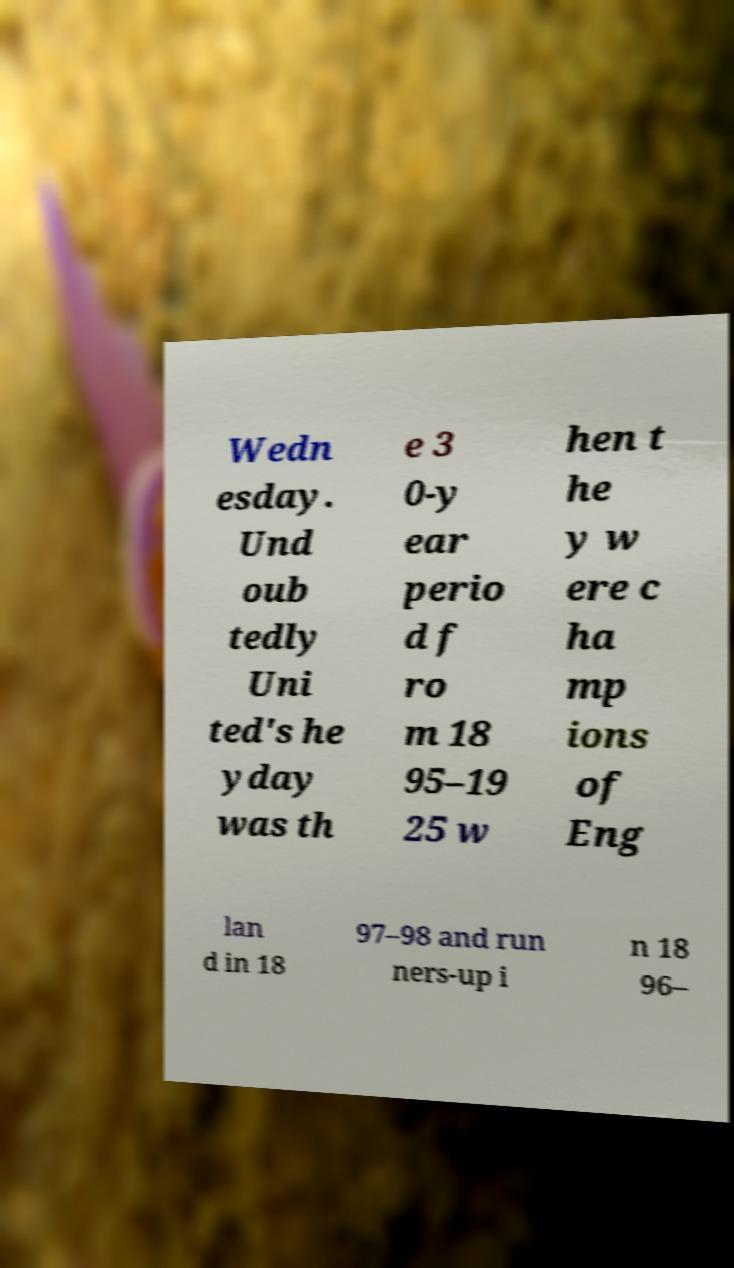I need the written content from this picture converted into text. Can you do that? Wedn esday. Und oub tedly Uni ted's he yday was th e 3 0-y ear perio d f ro m 18 95–19 25 w hen t he y w ere c ha mp ions of Eng lan d in 18 97–98 and run ners-up i n 18 96– 